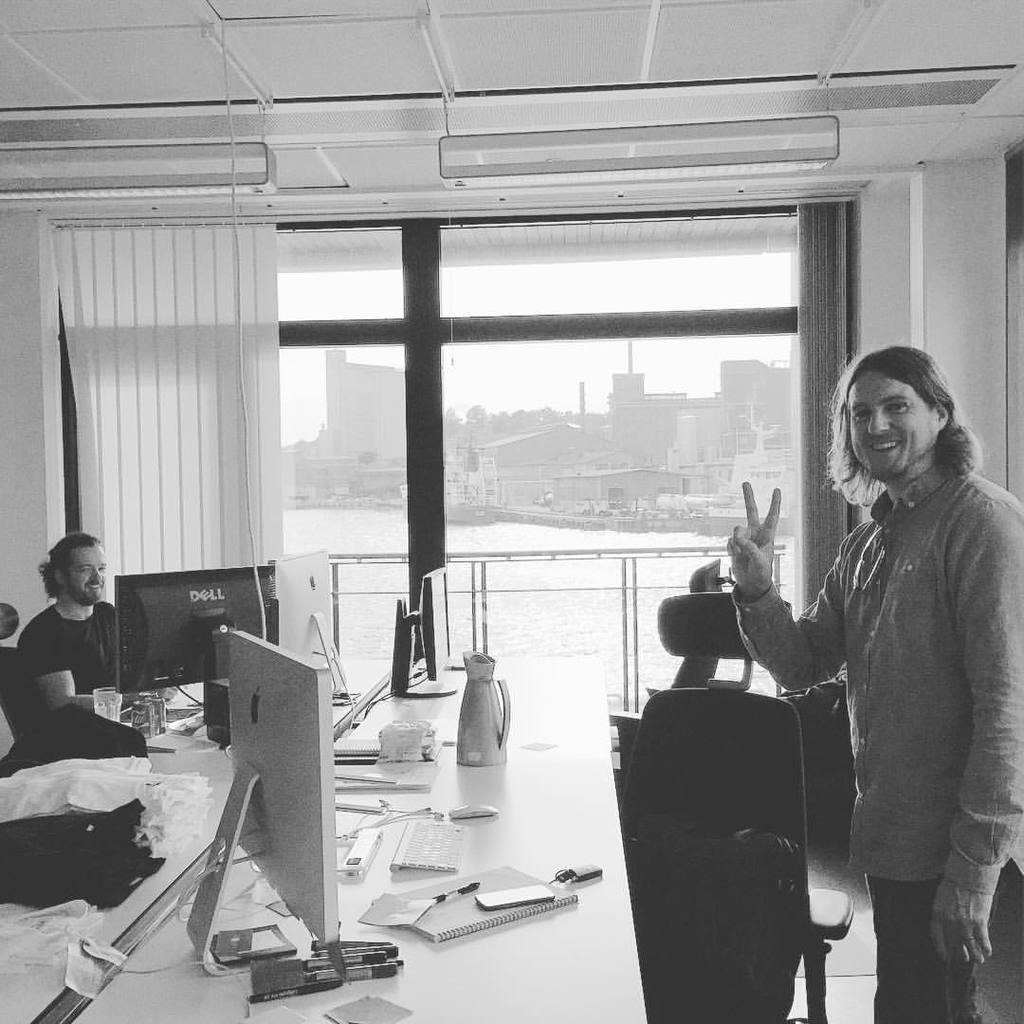How would you summarize this image in a sentence or two? This is a black and white picture. Here we can see windows and curtains. This is a ceiling. Here we can see a man standing in front of a chair and table. On the table we can see mobile, monitor, paper, keyboard, mouse, book and papers. Here we can see another man sitting in front of a monitor and on the table we can see glass. Through this window glass we can see huge buildings and a river. 